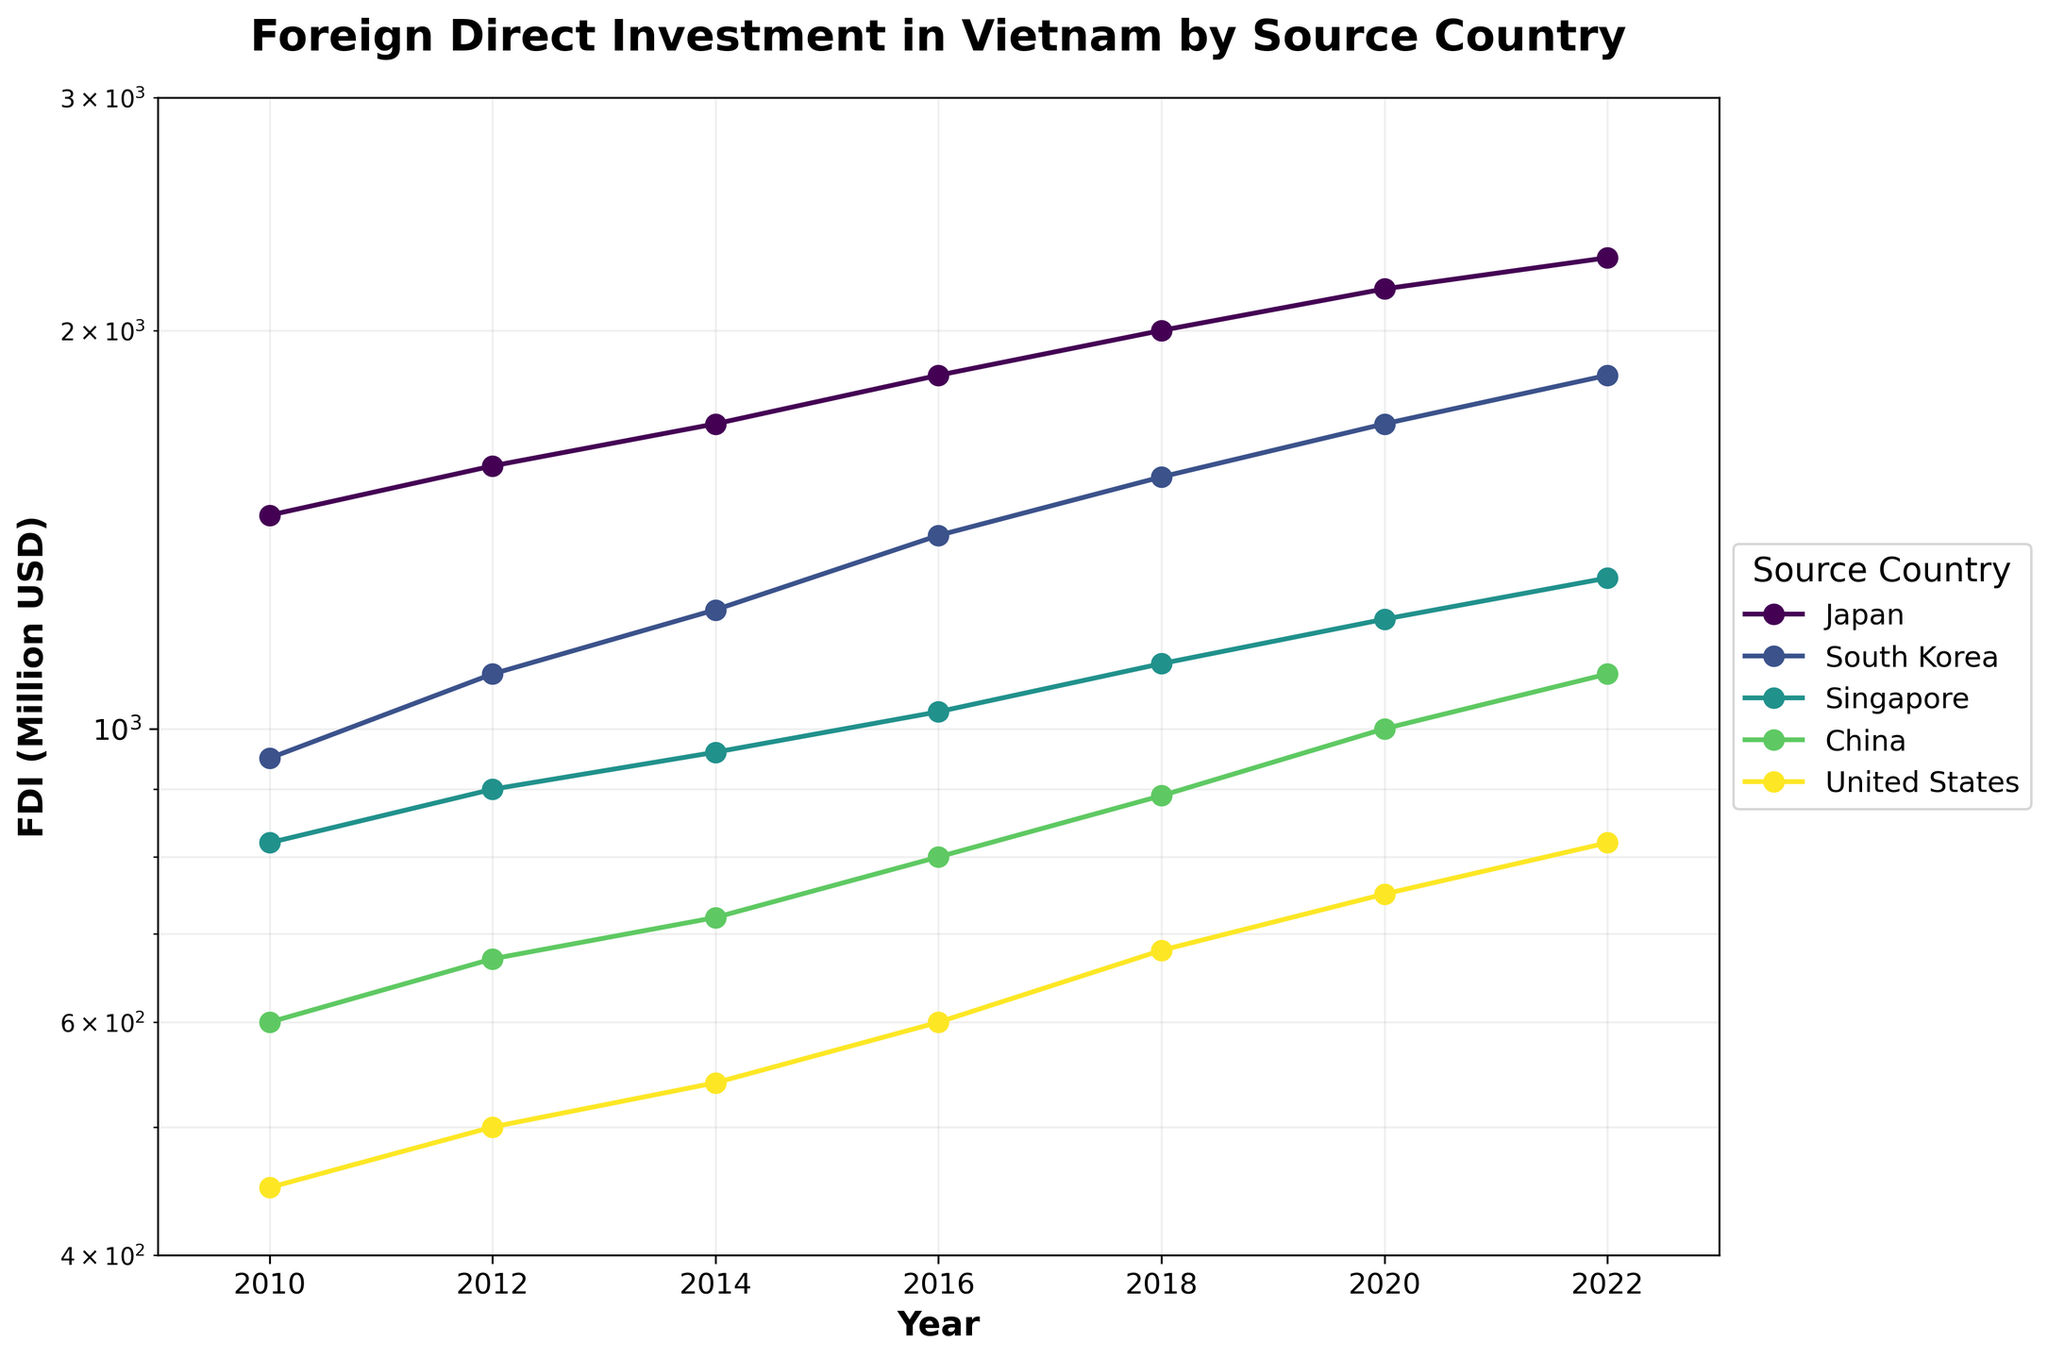What is the title of the figure? The title is located at the top of the figure.
Answer: Foreign Direct Investment in Vietnam by Source Country How many source countries are displayed in the figure? Count the number of unique colors or labels in the legend.
Answer: 5 What is the FDI value from Japan in the year 2010? Locate the data point for Japan in 2010 and read the corresponding value on the y-axis.
Answer: 1450 Million USD Which country had the highest FDI in 2022? Compare the FDI values for each country in the year 2022.
Answer: Japan How has South Korea's FDI changed from 2010 to 2022? Observe the trend for South Korea's data points from 2010 to 2022.
Answer: Increased What is the range of the FDI values on the y-axis? Identify the minimum and maximum values on the y-axis.
Answer: 400 to 3000 Million USD In which year did Singapore have the highest FDI value? Look for Singapore's highest data point across all years and note the corresponding year.
Answer: 2022 What is the average FDI from China from 2010 to 2022? Sum the FDI values for China from 2010 to 2022 and divide by the number of years.
Answer: (600 + 670 + 720 + 800 + 890 + 1000 + 1100) / 7 = 820 Million USD Which two countries are closest in FDI value in 2020? Compare the FDI values of all countries in 2020 and find the pair with the smallest difference.
Answer: China and Singapore Has the United States' FDI shown a steady increase, decrease, or fluctuation over time? Analyze the trend of the United States' data points from 2010 to 2022 to determine the pattern.
Answer: Fluctuation 